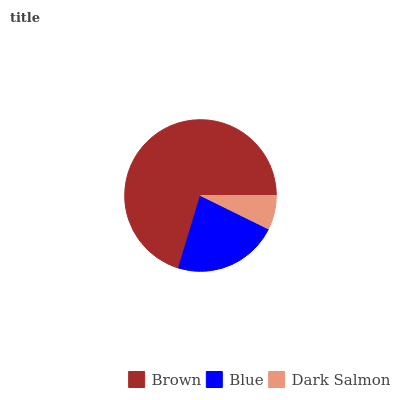Is Dark Salmon the minimum?
Answer yes or no. Yes. Is Brown the maximum?
Answer yes or no. Yes. Is Blue the minimum?
Answer yes or no. No. Is Blue the maximum?
Answer yes or no. No. Is Brown greater than Blue?
Answer yes or no. Yes. Is Blue less than Brown?
Answer yes or no. Yes. Is Blue greater than Brown?
Answer yes or no. No. Is Brown less than Blue?
Answer yes or no. No. Is Blue the high median?
Answer yes or no. Yes. Is Blue the low median?
Answer yes or no. Yes. Is Brown the high median?
Answer yes or no. No. Is Dark Salmon the low median?
Answer yes or no. No. 